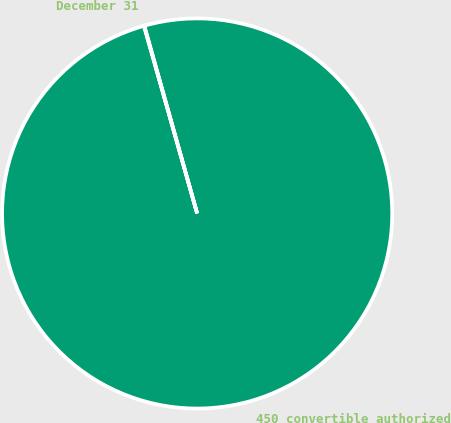Convert chart. <chart><loc_0><loc_0><loc_500><loc_500><pie_chart><fcel>December 31<fcel>450 convertible authorized<nl><fcel>0.04%<fcel>99.96%<nl></chart> 